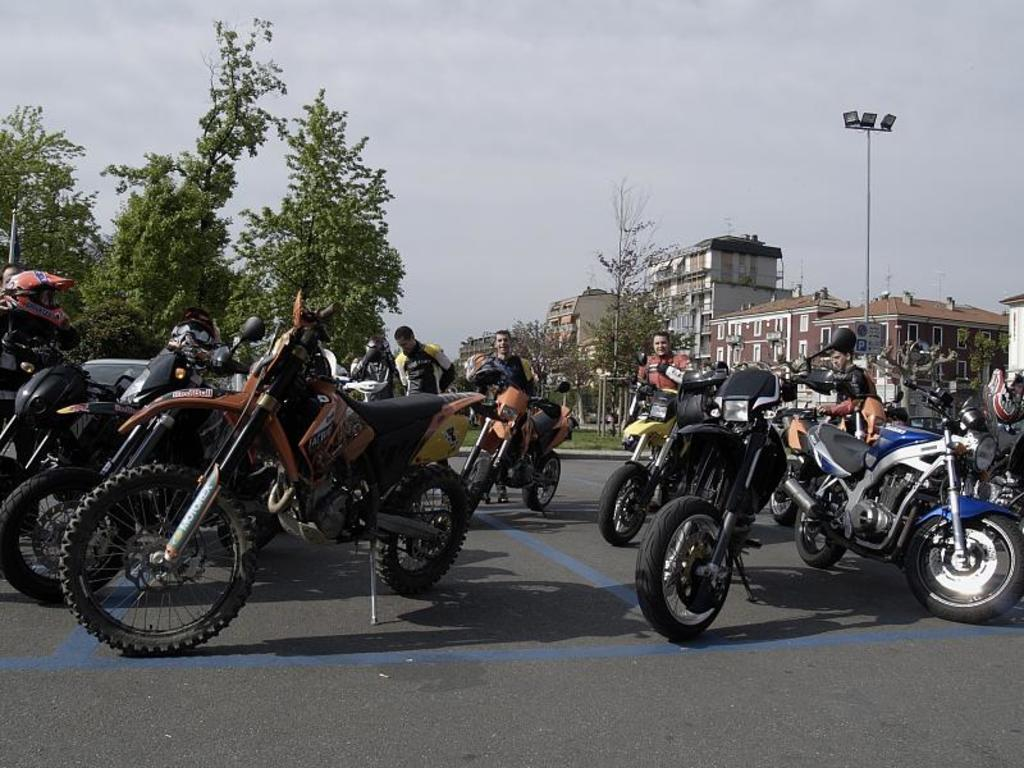What can be seen on the road in the image? There are vehicles and persons on the road in the image. What type of vegetation is visible in the image? There are trees visible in the image. What is the structure with windows in the image? There is a building with windows in the image. What is attached to the pole in the image? There are lights attached to the pole in the image. What is visible in the background of the image? The sky is visible in the background of the image. Can you tell me how many robins are sitting on the table in the image? There is no table or robin present in the image. What type of ant is crawling on the building in the image? There are no ants visible in the image; only vehicles, persons, trees, a building, a pole with lights, and the sky are present. 